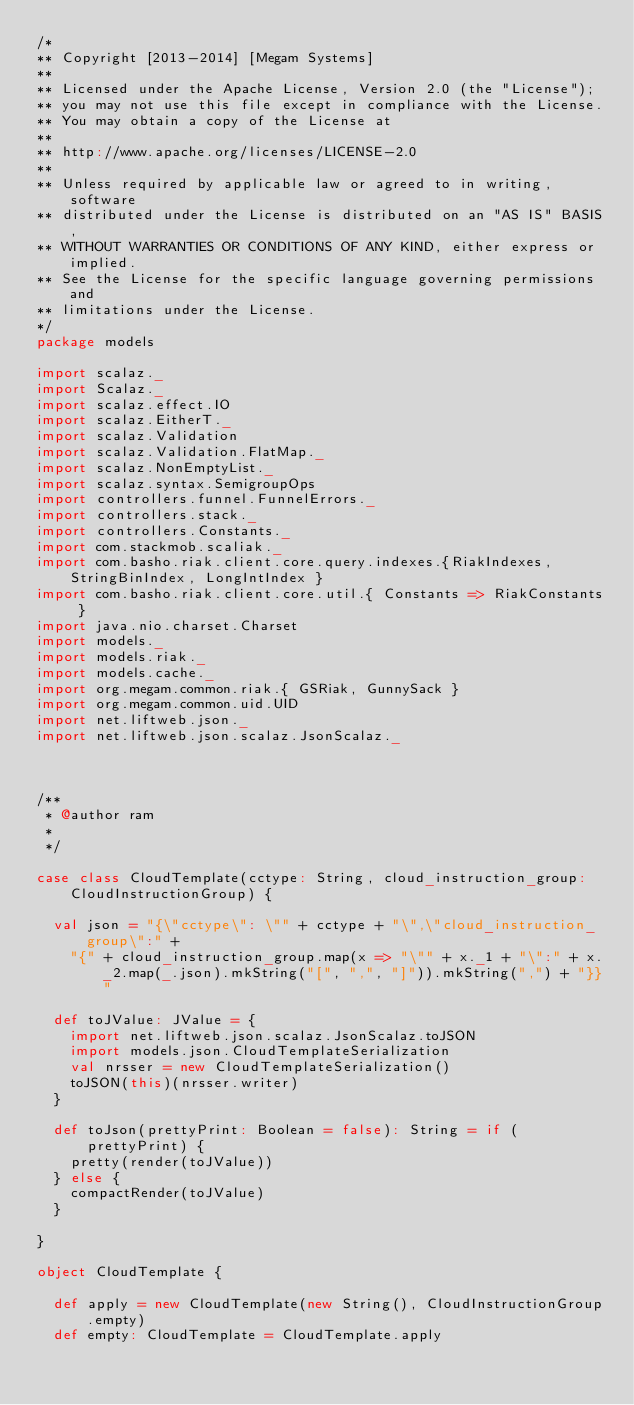Convert code to text. <code><loc_0><loc_0><loc_500><loc_500><_Scala_>/* 
** Copyright [2013-2014] [Megam Systems]
**
** Licensed under the Apache License, Version 2.0 (the "License");
** you may not use this file except in compliance with the License.
** You may obtain a copy of the License at
**
** http://www.apache.org/licenses/LICENSE-2.0
**
** Unless required by applicable law or agreed to in writing, software
** distributed under the License is distributed on an "AS IS" BASIS,
** WITHOUT WARRANTIES OR CONDITIONS OF ANY KIND, either express or implied.
** See the License for the specific language governing permissions and
** limitations under the License.
*/
package models

import scalaz._
import Scalaz._
import scalaz.effect.IO
import scalaz.EitherT._
import scalaz.Validation
import scalaz.Validation.FlatMap._
import scalaz.NonEmptyList._
import scalaz.syntax.SemigroupOps
import controllers.funnel.FunnelErrors._
import controllers.stack._
import controllers.Constants._
import com.stackmob.scaliak._
import com.basho.riak.client.core.query.indexes.{RiakIndexes, StringBinIndex, LongIntIndex }
import com.basho.riak.client.core.util.{ Constants => RiakConstants }
import java.nio.charset.Charset
import models._
import models.riak._
import models.cache._
import org.megam.common.riak.{ GSRiak, GunnySack }
import org.megam.common.uid.UID
import net.liftweb.json._
import net.liftweb.json.scalaz.JsonScalaz._



/**
 * @author ram
 *
 */

case class CloudTemplate(cctype: String, cloud_instruction_group: CloudInstructionGroup) {

  val json = "{\"cctype\": \"" + cctype + "\",\"cloud_instruction_group\":" +
    "{" + cloud_instruction_group.map(x => "\"" + x._1 + "\":" + x._2.map(_.json).mkString("[", ",", "]")).mkString(",") + "}}"

  def toJValue: JValue = {
    import net.liftweb.json.scalaz.JsonScalaz.toJSON
    import models.json.CloudTemplateSerialization
    val nrsser = new CloudTemplateSerialization()
    toJSON(this)(nrsser.writer)
  }

  def toJson(prettyPrint: Boolean = false): String = if (prettyPrint) {
    pretty(render(toJValue))
  } else {
    compactRender(toJValue)
  }

}

object CloudTemplate {

  def apply = new CloudTemplate(new String(), CloudInstructionGroup.empty)
  def empty: CloudTemplate = CloudTemplate.apply
</code> 